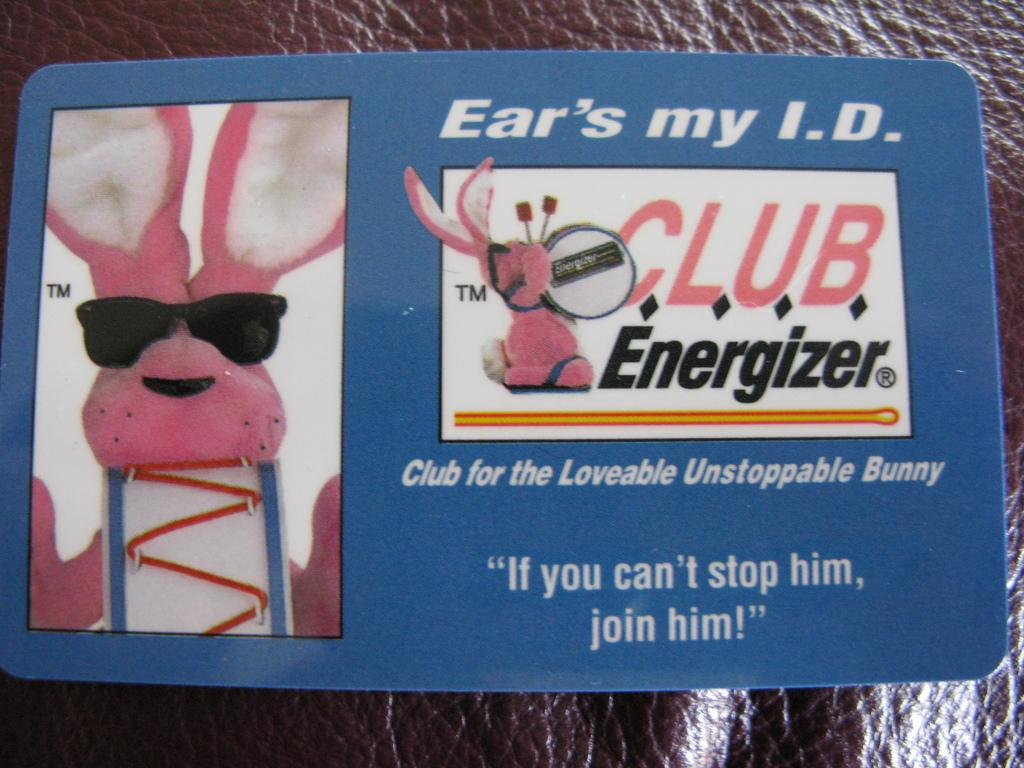What type of document is shown in the image? The image appears to be an identity card. What image is featured on the identity card? There is a picture of a rabbit on the identity card. What else can be seen on the identity card besides the image? There are letters on the identity card. What is the background of the identity card made of? The background of the identity card looks like a leather cloth. What color is the leather cloth? The leather cloth is brown in color. Can you tell me how many buns are placed on the guitar in the image? There is no guitar or buns present in the image; it features an identity card with a picture of a rabbit and a brown leather cloth background. 